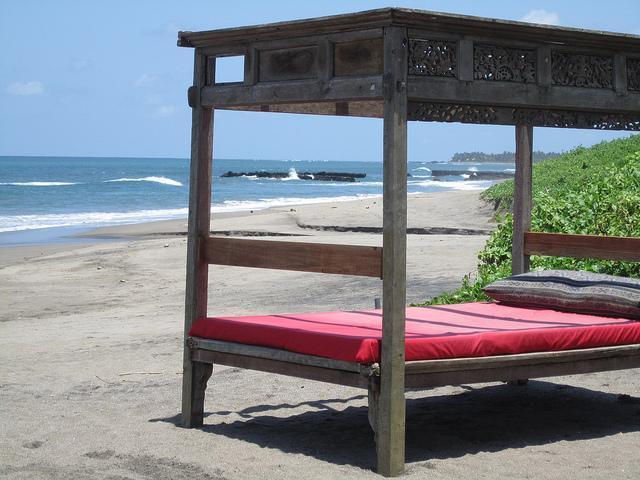How many kites are up in the air?
Give a very brief answer. 0. 